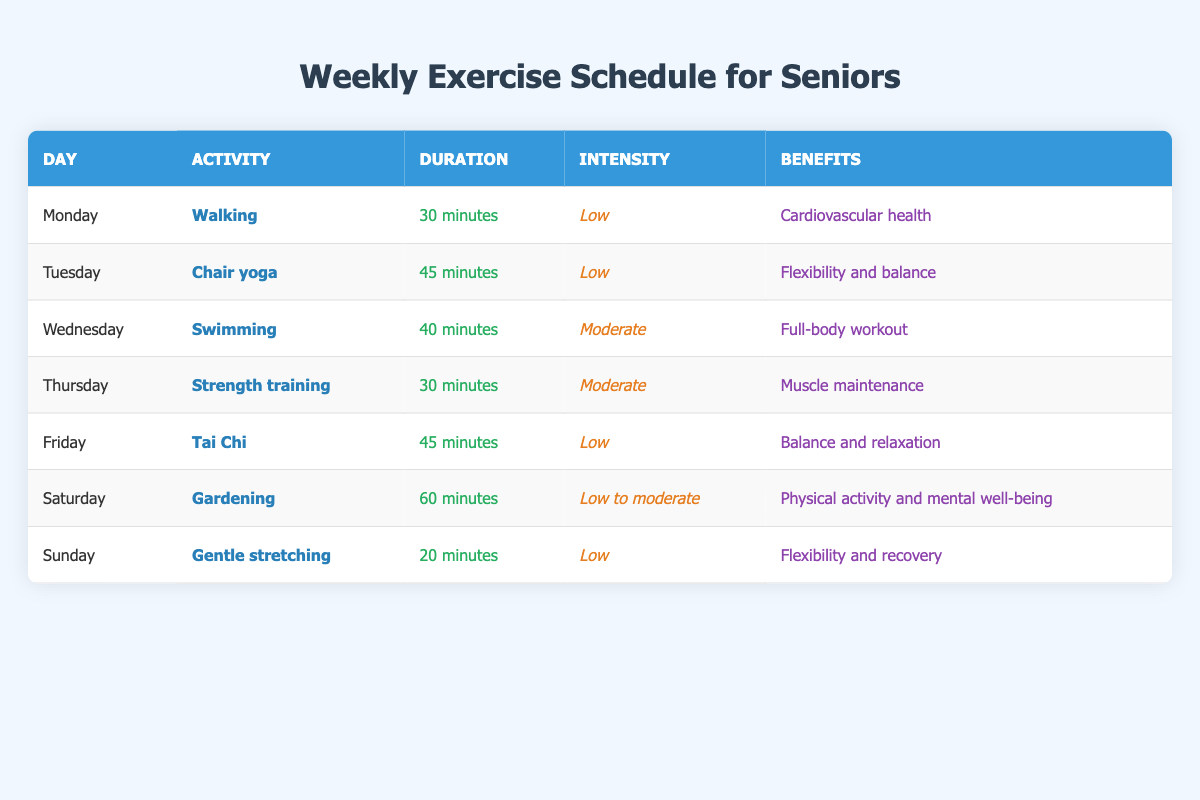What activity is scheduled for Wednesday? The table lists the activities for each day. Looking at the row for Wednesday, the activity is swimming.
Answer: Swimming How long is the duration of Tai Chi? By checking the row for Friday, we can see that Tai Chi lasts for 45 minutes.
Answer: 45 minutes Is strength training considered a low-intensity activity? The intensity for strength training is marked as moderate in the table, which means it is not low intensity.
Answer: No What are the benefits of gardening according to the table? If we check the row for Saturday, we see that the benefits listed for gardening are physical activity and mental well-being.
Answer: Physical activity and mental well-being Which two activities have the highest duration and what is that duration? Looking through the table, we find gardening has a duration of 60 minutes, and chair yoga has a duration of 45 minutes. The highest duration is 60 minutes.
Answer: 60 minutes On which day is gentle stretching performed? The table indicates gentle stretching is scheduled for Sunday.
Answer: Sunday What is the average duration of the activities listed from Monday to Thursday? The durations from Monday to Thursday are 30, 45, 40, and 30 minutes. Adding those gives 30 + 45 + 40 + 30 = 145 minutes. Dividing by 4 (the number of days) gives an average of 36.25 minutes.
Answer: 36.25 minutes Is the intensity of swimming higher than that of chair yoga? Swimming is marked as moderate intensity while chair yoga is marked as low intensity, indicating that swimming has a higher intensity.
Answer: Yes What are the benefits of activities performed on days with low intensity? The activities with low intensity are walking, chair yoga, Tai Chi, and gentle stretching. Their benefits are cardiovascular health, flexibility and balance, balance and relaxation, and flexibility and recovery, respectively.
Answer: Cardiovascular health, flexibility and balance, balance and relaxation, flexibility and recovery 